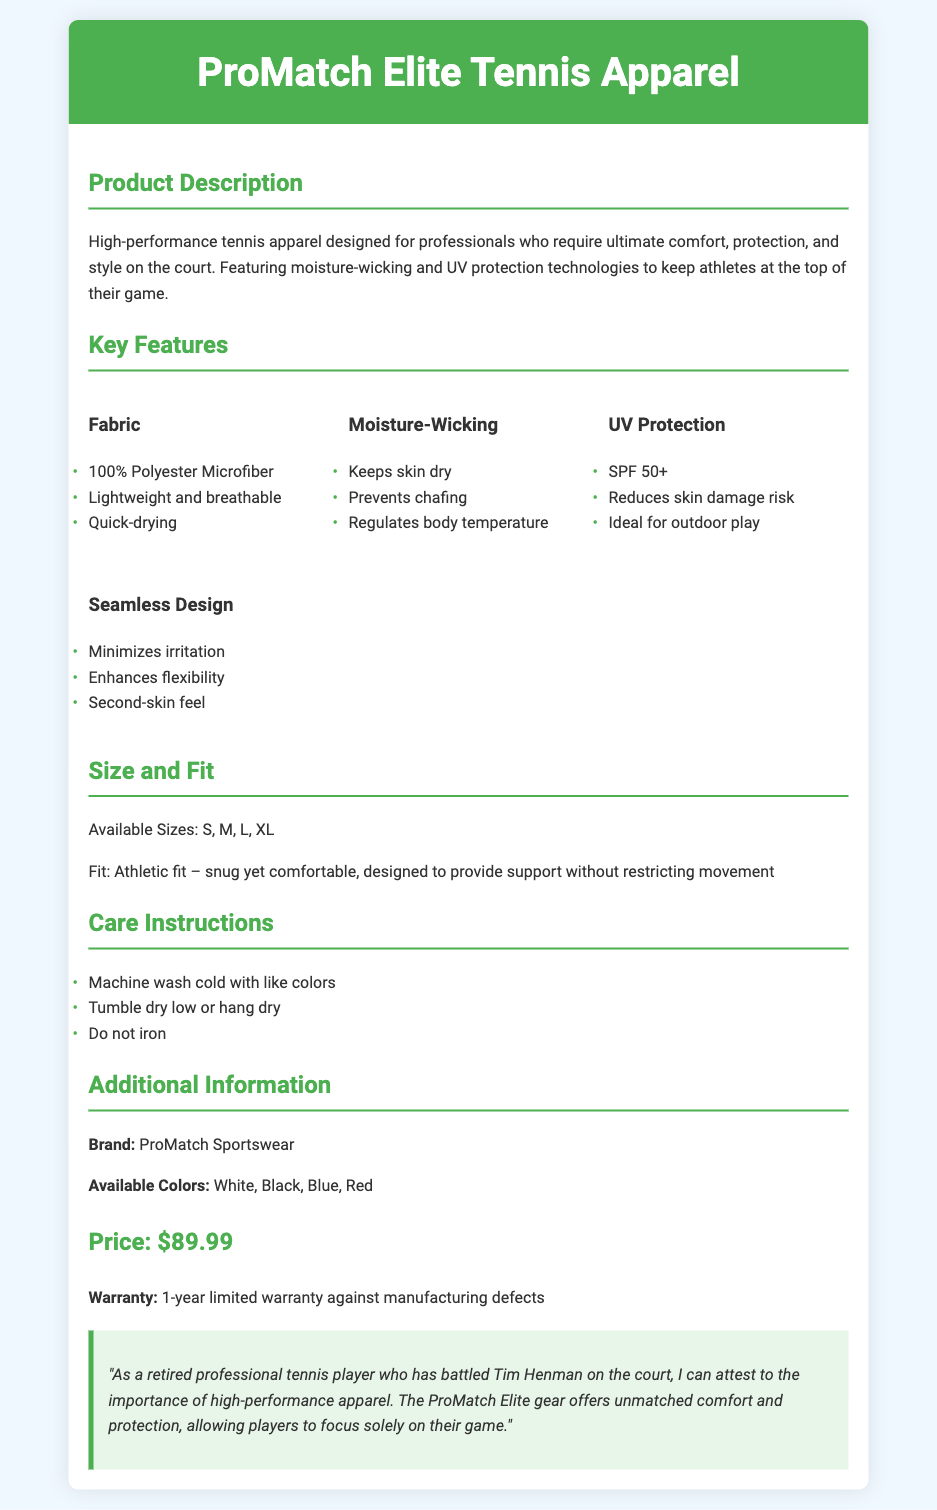what is the main product featured in the document? The main product is described in the product description section.
Answer: ProMatch Elite Tennis Apparel what is the fabric used in the apparel? The fabric section lists the material used in the apparel.
Answer: 100% Polyester Microfiber what protection does the apparel offer against UV rays? The UV protection section specifies the level of protection provided by the apparel.
Answer: SPF 50+ what sizes are available for the apparel? The size and fit section outlines the available sizes.
Answer: S, M, L, XL what is the price of the ProMatch Elite Tennis Apparel? The additional information section includes the price of the product.
Answer: $89.99 how should the apparel be washed? The care instructions section provides guidance on how to wash the apparel.
Answer: Machine wash cold with like colors which company produces the ProMatch Elite Tennis Apparel? The additional information section identifies the brand of the product.
Answer: ProMatch Sportswear what is the warranty duration for the apparel? The additional information section mentions the warranty against manufacturing defects.
Answer: 1-year limited warranty what feature helps minimize irritation during wear? The seamless design section describes a feature that reduces irritation.
Answer: Minimizes irritation 